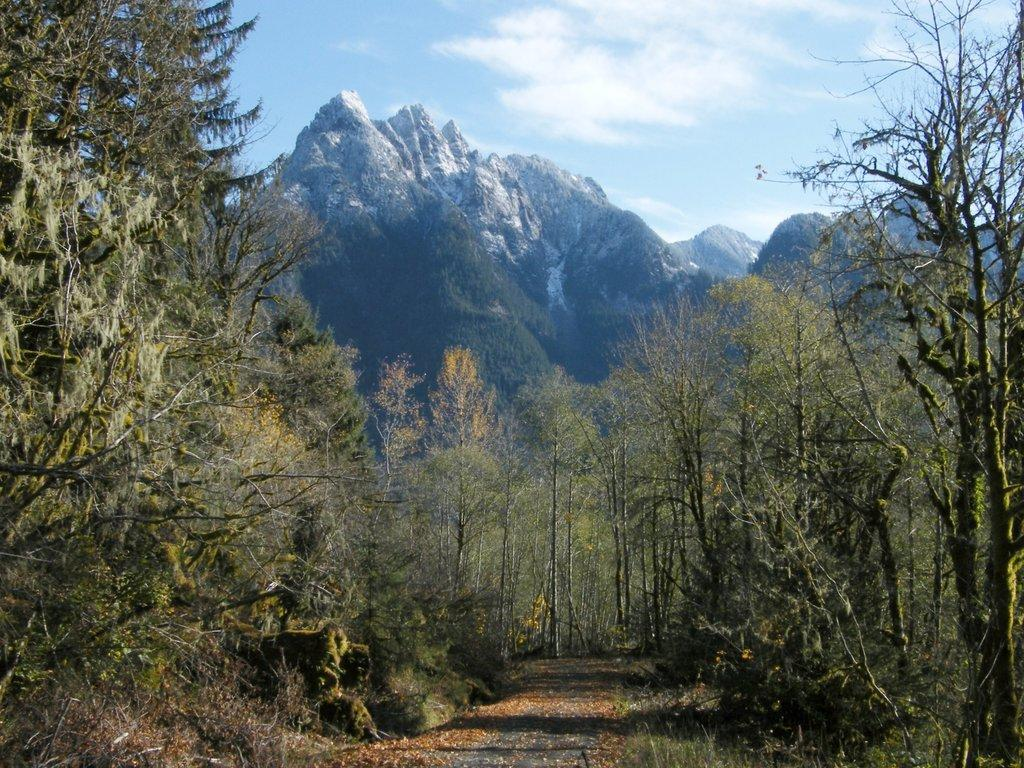What type of ground surface is visible in the image? There is grass on the ground in the image. What other natural elements can be seen in the image? There are plants and trees in the image. How are the trees in the image described? The trees are covered. What can be seen in the far distance of the image? There are mountains in the far distance of the image. What is the condition of the mountains in the image? The mountains are covered with snow. What is visible in the sky in the image? There are clouds visible in the sky. What type of apparatus is being used to attempt to extract a substance from the clouds in the image? There is no apparatus or attempt to extract a substance from the clouds in the image; the clouds are simply visible in the sky. 